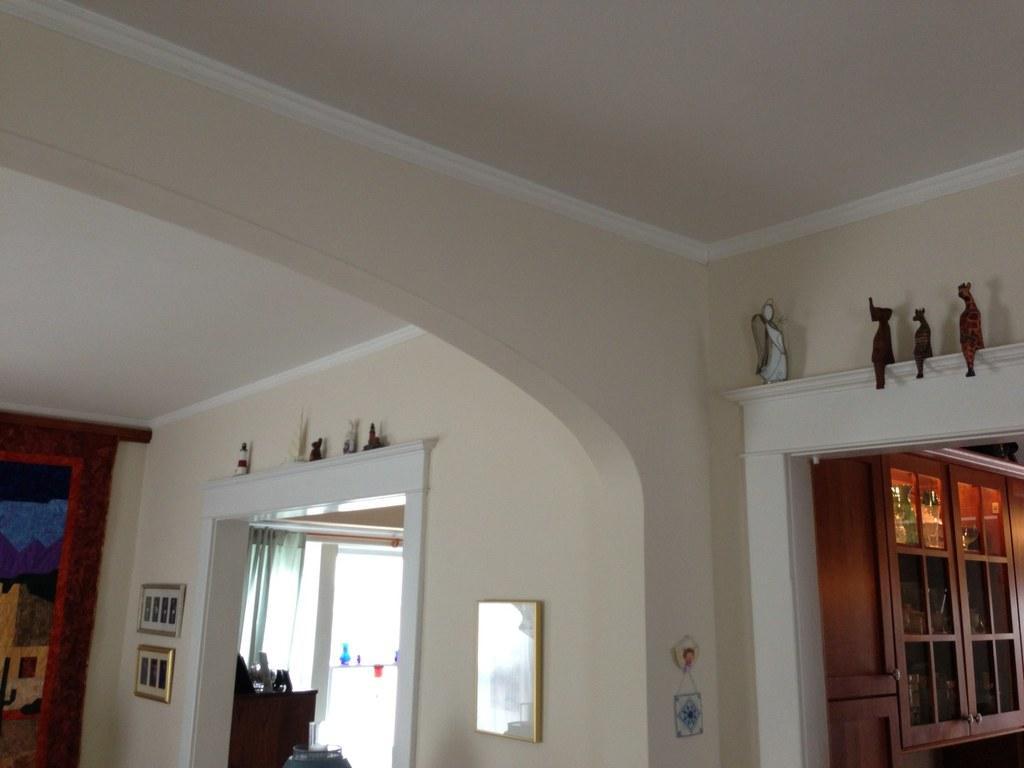Please provide a concise description of this image. This image is clicked inside a house. On the right there are cupboards, toys and wall. In the middle there is a frame. On the left there are windows, curtains, table, photo frames, toys and wall. 